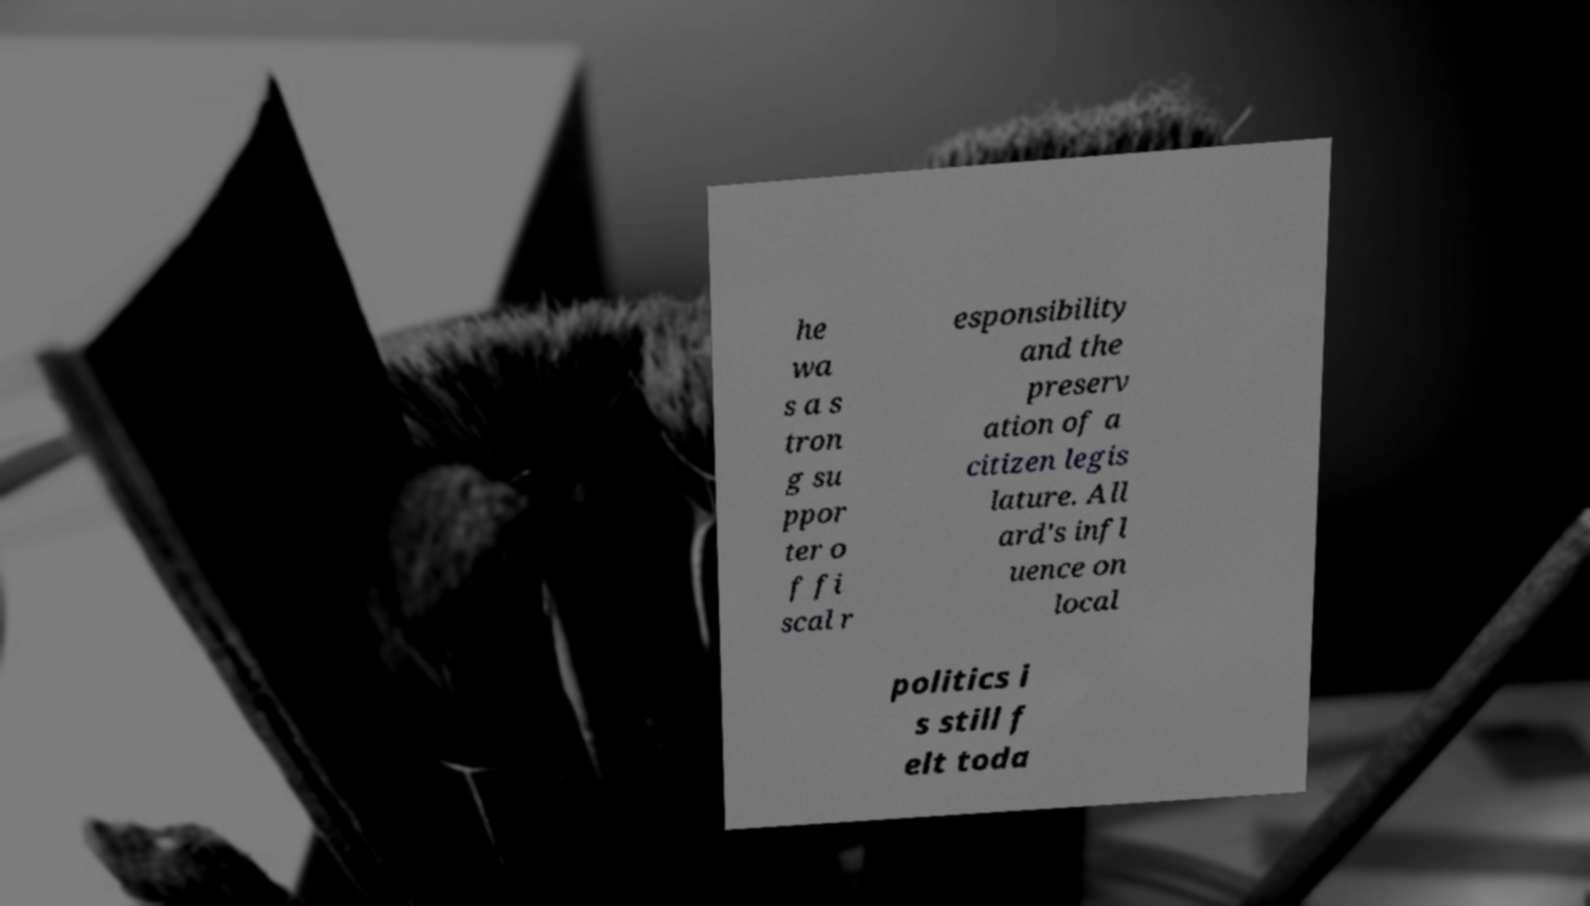Can you accurately transcribe the text from the provided image for me? he wa s a s tron g su ppor ter o f fi scal r esponsibility and the preserv ation of a citizen legis lature. All ard's infl uence on local politics i s still f elt toda 